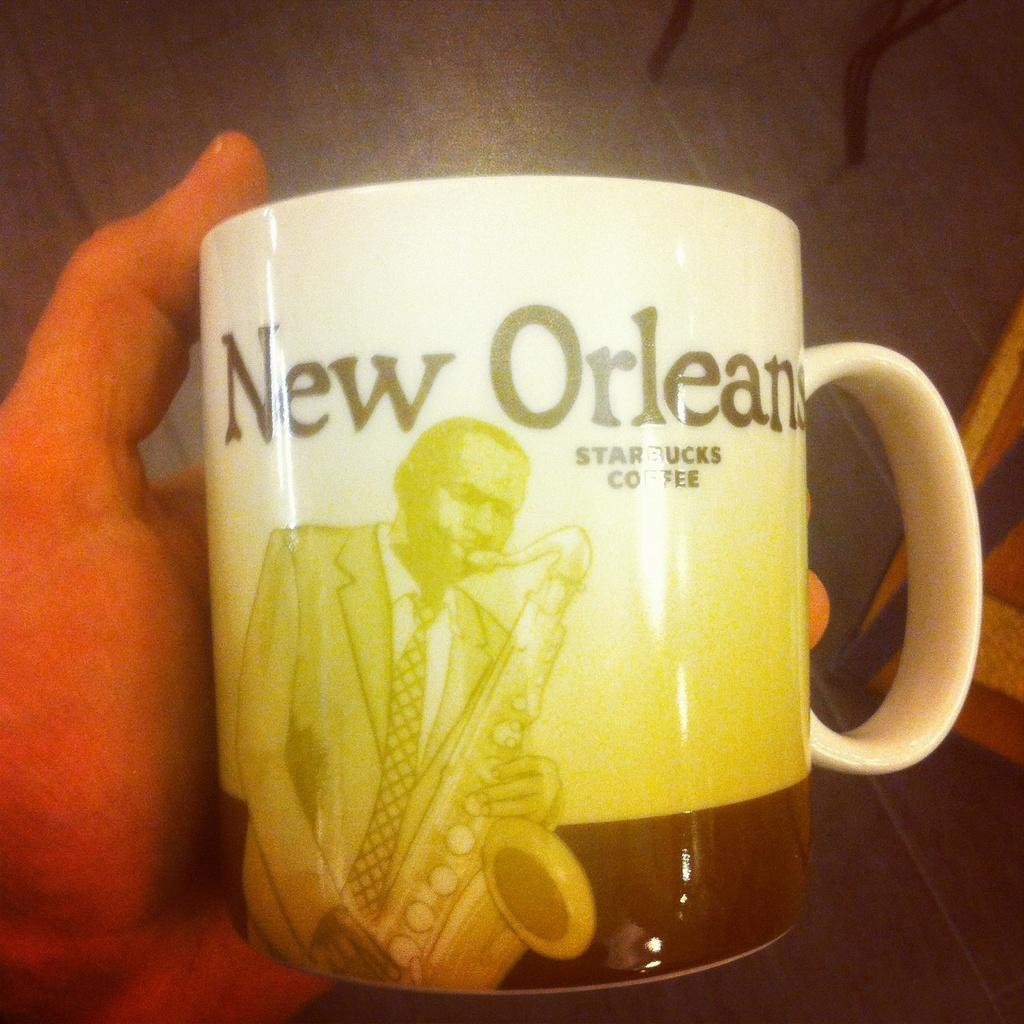<image>
Present a compact description of the photo's key features. A starbucks coffee cup from New Orleans with a sax player on it. 